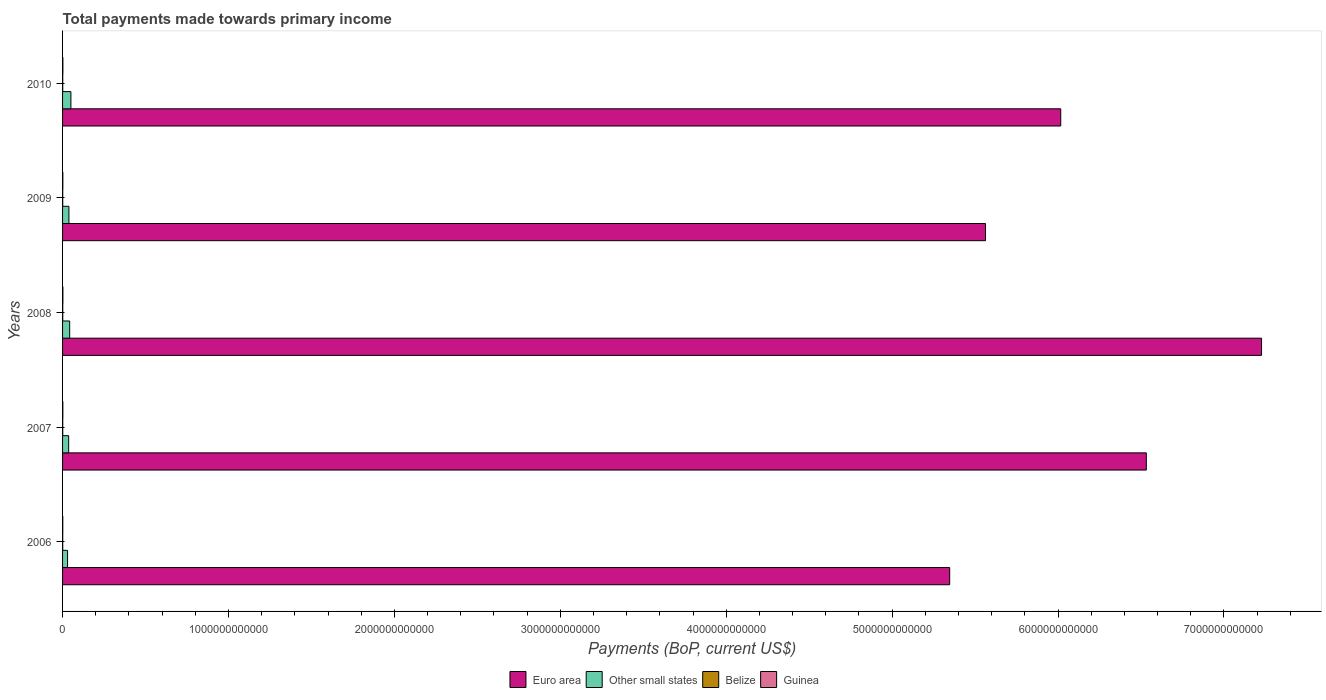How many groups of bars are there?
Your answer should be very brief. 5. How many bars are there on the 2nd tick from the top?
Ensure brevity in your answer.  4. What is the label of the 4th group of bars from the top?
Provide a succinct answer. 2007. What is the total payments made towards primary income in Other small states in 2009?
Provide a short and direct response. 3.83e+1. Across all years, what is the maximum total payments made towards primary income in Euro area?
Provide a short and direct response. 7.23e+12. Across all years, what is the minimum total payments made towards primary income in Other small states?
Your response must be concise. 3.01e+1. What is the total total payments made towards primary income in Other small states in the graph?
Your answer should be compact. 1.98e+11. What is the difference between the total payments made towards primary income in Belize in 2008 and that in 2010?
Ensure brevity in your answer.  1.57e+08. What is the difference between the total payments made towards primary income in Euro area in 2008 and the total payments made towards primary income in Belize in 2007?
Make the answer very short. 7.23e+12. What is the average total payments made towards primary income in Belize per year?
Your answer should be very brief. 9.70e+08. In the year 2006, what is the difference between the total payments made towards primary income in Euro area and total payments made towards primary income in Guinea?
Make the answer very short. 5.35e+12. What is the ratio of the total payments made towards primary income in Guinea in 2007 to that in 2010?
Provide a succinct answer. 0.86. What is the difference between the highest and the second highest total payments made towards primary income in Euro area?
Give a very brief answer. 6.94e+11. What is the difference between the highest and the lowest total payments made towards primary income in Guinea?
Your answer should be compact. 6.13e+08. In how many years, is the total payments made towards primary income in Other small states greater than the average total payments made towards primary income in Other small states taken over all years?
Your answer should be compact. 2. Is the sum of the total payments made towards primary income in Guinea in 2008 and 2009 greater than the maximum total payments made towards primary income in Euro area across all years?
Keep it short and to the point. No. What does the 2nd bar from the bottom in 2007 represents?
Offer a terse response. Other small states. How many bars are there?
Offer a very short reply. 20. How many years are there in the graph?
Offer a terse response. 5. What is the difference between two consecutive major ticks on the X-axis?
Ensure brevity in your answer.  1.00e+12. Does the graph contain grids?
Give a very brief answer. No. How are the legend labels stacked?
Your answer should be very brief. Horizontal. What is the title of the graph?
Ensure brevity in your answer.  Total payments made towards primary income. What is the label or title of the X-axis?
Your answer should be compact. Payments (BoP, current US$). What is the label or title of the Y-axis?
Your response must be concise. Years. What is the Payments (BoP, current US$) in Euro area in 2006?
Keep it short and to the point. 5.35e+12. What is the Payments (BoP, current US$) of Other small states in 2006?
Give a very brief answer. 3.01e+1. What is the Payments (BoP, current US$) of Belize in 2006?
Provide a succinct answer. 8.85e+08. What is the Payments (BoP, current US$) of Guinea in 2006?
Keep it short and to the point. 1.30e+09. What is the Payments (BoP, current US$) in Euro area in 2007?
Your response must be concise. 6.53e+12. What is the Payments (BoP, current US$) of Other small states in 2007?
Ensure brevity in your answer.  3.68e+1. What is the Payments (BoP, current US$) in Belize in 2007?
Offer a very short reply. 9.69e+08. What is the Payments (BoP, current US$) of Guinea in 2007?
Your answer should be very brief. 1.64e+09. What is the Payments (BoP, current US$) of Euro area in 2008?
Provide a short and direct response. 7.23e+12. What is the Payments (BoP, current US$) in Other small states in 2008?
Give a very brief answer. 4.29e+1. What is the Payments (BoP, current US$) in Belize in 2008?
Provide a succinct answer. 1.13e+09. What is the Payments (BoP, current US$) of Guinea in 2008?
Provide a succinct answer. 1.91e+09. What is the Payments (BoP, current US$) in Euro area in 2009?
Provide a short and direct response. 5.56e+12. What is the Payments (BoP, current US$) in Other small states in 2009?
Keep it short and to the point. 3.83e+1. What is the Payments (BoP, current US$) of Belize in 2009?
Offer a terse response. 8.95e+08. What is the Payments (BoP, current US$) of Guinea in 2009?
Your response must be concise. 1.58e+09. What is the Payments (BoP, current US$) in Euro area in 2010?
Provide a short and direct response. 6.02e+12. What is the Payments (BoP, current US$) in Other small states in 2010?
Provide a succinct answer. 5.03e+1. What is the Payments (BoP, current US$) in Belize in 2010?
Make the answer very short. 9.72e+08. What is the Payments (BoP, current US$) of Guinea in 2010?
Ensure brevity in your answer.  1.89e+09. Across all years, what is the maximum Payments (BoP, current US$) of Euro area?
Your answer should be very brief. 7.23e+12. Across all years, what is the maximum Payments (BoP, current US$) of Other small states?
Provide a succinct answer. 5.03e+1. Across all years, what is the maximum Payments (BoP, current US$) in Belize?
Make the answer very short. 1.13e+09. Across all years, what is the maximum Payments (BoP, current US$) of Guinea?
Make the answer very short. 1.91e+09. Across all years, what is the minimum Payments (BoP, current US$) of Euro area?
Make the answer very short. 5.35e+12. Across all years, what is the minimum Payments (BoP, current US$) in Other small states?
Provide a succinct answer. 3.01e+1. Across all years, what is the minimum Payments (BoP, current US$) of Belize?
Your answer should be very brief. 8.85e+08. Across all years, what is the minimum Payments (BoP, current US$) in Guinea?
Provide a short and direct response. 1.30e+09. What is the total Payments (BoP, current US$) in Euro area in the graph?
Provide a short and direct response. 3.07e+13. What is the total Payments (BoP, current US$) in Other small states in the graph?
Offer a terse response. 1.98e+11. What is the total Payments (BoP, current US$) in Belize in the graph?
Keep it short and to the point. 4.85e+09. What is the total Payments (BoP, current US$) of Guinea in the graph?
Keep it short and to the point. 8.32e+09. What is the difference between the Payments (BoP, current US$) in Euro area in 2006 and that in 2007?
Your response must be concise. -1.19e+12. What is the difference between the Payments (BoP, current US$) in Other small states in 2006 and that in 2007?
Make the answer very short. -6.70e+09. What is the difference between the Payments (BoP, current US$) in Belize in 2006 and that in 2007?
Provide a short and direct response. -8.34e+07. What is the difference between the Payments (BoP, current US$) of Guinea in 2006 and that in 2007?
Give a very brief answer. -3.39e+08. What is the difference between the Payments (BoP, current US$) in Euro area in 2006 and that in 2008?
Your answer should be compact. -1.88e+12. What is the difference between the Payments (BoP, current US$) of Other small states in 2006 and that in 2008?
Provide a short and direct response. -1.28e+1. What is the difference between the Payments (BoP, current US$) in Belize in 2006 and that in 2008?
Your answer should be very brief. -2.44e+08. What is the difference between the Payments (BoP, current US$) of Guinea in 2006 and that in 2008?
Offer a very short reply. -6.13e+08. What is the difference between the Payments (BoP, current US$) in Euro area in 2006 and that in 2009?
Offer a very short reply. -2.16e+11. What is the difference between the Payments (BoP, current US$) of Other small states in 2006 and that in 2009?
Ensure brevity in your answer.  -8.19e+09. What is the difference between the Payments (BoP, current US$) of Belize in 2006 and that in 2009?
Provide a short and direct response. -9.58e+06. What is the difference between the Payments (BoP, current US$) of Guinea in 2006 and that in 2009?
Your answer should be compact. -2.83e+08. What is the difference between the Payments (BoP, current US$) in Euro area in 2006 and that in 2010?
Make the answer very short. -6.69e+11. What is the difference between the Payments (BoP, current US$) in Other small states in 2006 and that in 2010?
Provide a short and direct response. -2.01e+1. What is the difference between the Payments (BoP, current US$) in Belize in 2006 and that in 2010?
Provide a short and direct response. -8.63e+07. What is the difference between the Payments (BoP, current US$) in Guinea in 2006 and that in 2010?
Your answer should be very brief. -5.94e+08. What is the difference between the Payments (BoP, current US$) in Euro area in 2007 and that in 2008?
Provide a short and direct response. -6.94e+11. What is the difference between the Payments (BoP, current US$) of Other small states in 2007 and that in 2008?
Your response must be concise. -6.08e+09. What is the difference between the Payments (BoP, current US$) of Belize in 2007 and that in 2008?
Offer a very short reply. -1.60e+08. What is the difference between the Payments (BoP, current US$) of Guinea in 2007 and that in 2008?
Make the answer very short. -2.75e+08. What is the difference between the Payments (BoP, current US$) of Euro area in 2007 and that in 2009?
Give a very brief answer. 9.69e+11. What is the difference between the Payments (BoP, current US$) in Other small states in 2007 and that in 2009?
Ensure brevity in your answer.  -1.49e+09. What is the difference between the Payments (BoP, current US$) of Belize in 2007 and that in 2009?
Offer a terse response. 7.38e+07. What is the difference between the Payments (BoP, current US$) in Guinea in 2007 and that in 2009?
Offer a very short reply. 5.57e+07. What is the difference between the Payments (BoP, current US$) of Euro area in 2007 and that in 2010?
Your answer should be compact. 5.16e+11. What is the difference between the Payments (BoP, current US$) of Other small states in 2007 and that in 2010?
Give a very brief answer. -1.34e+1. What is the difference between the Payments (BoP, current US$) of Belize in 2007 and that in 2010?
Keep it short and to the point. -2.94e+06. What is the difference between the Payments (BoP, current US$) in Guinea in 2007 and that in 2010?
Ensure brevity in your answer.  -2.56e+08. What is the difference between the Payments (BoP, current US$) in Euro area in 2008 and that in 2009?
Your answer should be compact. 1.66e+12. What is the difference between the Payments (BoP, current US$) of Other small states in 2008 and that in 2009?
Provide a short and direct response. 4.59e+09. What is the difference between the Payments (BoP, current US$) in Belize in 2008 and that in 2009?
Keep it short and to the point. 2.34e+08. What is the difference between the Payments (BoP, current US$) of Guinea in 2008 and that in 2009?
Provide a short and direct response. 3.30e+08. What is the difference between the Payments (BoP, current US$) of Euro area in 2008 and that in 2010?
Offer a terse response. 1.21e+12. What is the difference between the Payments (BoP, current US$) of Other small states in 2008 and that in 2010?
Keep it short and to the point. -7.36e+09. What is the difference between the Payments (BoP, current US$) of Belize in 2008 and that in 2010?
Provide a short and direct response. 1.57e+08. What is the difference between the Payments (BoP, current US$) of Guinea in 2008 and that in 2010?
Your response must be concise. 1.90e+07. What is the difference between the Payments (BoP, current US$) in Euro area in 2009 and that in 2010?
Provide a short and direct response. -4.54e+11. What is the difference between the Payments (BoP, current US$) of Other small states in 2009 and that in 2010?
Keep it short and to the point. -1.20e+1. What is the difference between the Payments (BoP, current US$) of Belize in 2009 and that in 2010?
Give a very brief answer. -7.67e+07. What is the difference between the Payments (BoP, current US$) in Guinea in 2009 and that in 2010?
Make the answer very short. -3.11e+08. What is the difference between the Payments (BoP, current US$) in Euro area in 2006 and the Payments (BoP, current US$) in Other small states in 2007?
Your answer should be compact. 5.31e+12. What is the difference between the Payments (BoP, current US$) of Euro area in 2006 and the Payments (BoP, current US$) of Belize in 2007?
Provide a succinct answer. 5.35e+12. What is the difference between the Payments (BoP, current US$) of Euro area in 2006 and the Payments (BoP, current US$) of Guinea in 2007?
Ensure brevity in your answer.  5.35e+12. What is the difference between the Payments (BoP, current US$) of Other small states in 2006 and the Payments (BoP, current US$) of Belize in 2007?
Your response must be concise. 2.92e+1. What is the difference between the Payments (BoP, current US$) of Other small states in 2006 and the Payments (BoP, current US$) of Guinea in 2007?
Give a very brief answer. 2.85e+1. What is the difference between the Payments (BoP, current US$) of Belize in 2006 and the Payments (BoP, current US$) of Guinea in 2007?
Your response must be concise. -7.51e+08. What is the difference between the Payments (BoP, current US$) in Euro area in 2006 and the Payments (BoP, current US$) in Other small states in 2008?
Your answer should be compact. 5.30e+12. What is the difference between the Payments (BoP, current US$) in Euro area in 2006 and the Payments (BoP, current US$) in Belize in 2008?
Ensure brevity in your answer.  5.35e+12. What is the difference between the Payments (BoP, current US$) in Euro area in 2006 and the Payments (BoP, current US$) in Guinea in 2008?
Your answer should be very brief. 5.35e+12. What is the difference between the Payments (BoP, current US$) of Other small states in 2006 and the Payments (BoP, current US$) of Belize in 2008?
Offer a very short reply. 2.90e+1. What is the difference between the Payments (BoP, current US$) of Other small states in 2006 and the Payments (BoP, current US$) of Guinea in 2008?
Offer a terse response. 2.82e+1. What is the difference between the Payments (BoP, current US$) in Belize in 2006 and the Payments (BoP, current US$) in Guinea in 2008?
Offer a very short reply. -1.03e+09. What is the difference between the Payments (BoP, current US$) in Euro area in 2006 and the Payments (BoP, current US$) in Other small states in 2009?
Ensure brevity in your answer.  5.31e+12. What is the difference between the Payments (BoP, current US$) of Euro area in 2006 and the Payments (BoP, current US$) of Belize in 2009?
Provide a short and direct response. 5.35e+12. What is the difference between the Payments (BoP, current US$) of Euro area in 2006 and the Payments (BoP, current US$) of Guinea in 2009?
Offer a terse response. 5.35e+12. What is the difference between the Payments (BoP, current US$) of Other small states in 2006 and the Payments (BoP, current US$) of Belize in 2009?
Make the answer very short. 2.92e+1. What is the difference between the Payments (BoP, current US$) of Other small states in 2006 and the Payments (BoP, current US$) of Guinea in 2009?
Give a very brief answer. 2.85e+1. What is the difference between the Payments (BoP, current US$) in Belize in 2006 and the Payments (BoP, current US$) in Guinea in 2009?
Make the answer very short. -6.96e+08. What is the difference between the Payments (BoP, current US$) in Euro area in 2006 and the Payments (BoP, current US$) in Other small states in 2010?
Your answer should be very brief. 5.30e+12. What is the difference between the Payments (BoP, current US$) of Euro area in 2006 and the Payments (BoP, current US$) of Belize in 2010?
Give a very brief answer. 5.35e+12. What is the difference between the Payments (BoP, current US$) in Euro area in 2006 and the Payments (BoP, current US$) in Guinea in 2010?
Your answer should be compact. 5.35e+12. What is the difference between the Payments (BoP, current US$) of Other small states in 2006 and the Payments (BoP, current US$) of Belize in 2010?
Offer a very short reply. 2.91e+1. What is the difference between the Payments (BoP, current US$) in Other small states in 2006 and the Payments (BoP, current US$) in Guinea in 2010?
Your answer should be very brief. 2.82e+1. What is the difference between the Payments (BoP, current US$) in Belize in 2006 and the Payments (BoP, current US$) in Guinea in 2010?
Your answer should be compact. -1.01e+09. What is the difference between the Payments (BoP, current US$) of Euro area in 2007 and the Payments (BoP, current US$) of Other small states in 2008?
Your answer should be very brief. 6.49e+12. What is the difference between the Payments (BoP, current US$) of Euro area in 2007 and the Payments (BoP, current US$) of Belize in 2008?
Keep it short and to the point. 6.53e+12. What is the difference between the Payments (BoP, current US$) of Euro area in 2007 and the Payments (BoP, current US$) of Guinea in 2008?
Your response must be concise. 6.53e+12. What is the difference between the Payments (BoP, current US$) of Other small states in 2007 and the Payments (BoP, current US$) of Belize in 2008?
Offer a terse response. 3.57e+1. What is the difference between the Payments (BoP, current US$) in Other small states in 2007 and the Payments (BoP, current US$) in Guinea in 2008?
Your answer should be compact. 3.49e+1. What is the difference between the Payments (BoP, current US$) of Belize in 2007 and the Payments (BoP, current US$) of Guinea in 2008?
Keep it short and to the point. -9.43e+08. What is the difference between the Payments (BoP, current US$) in Euro area in 2007 and the Payments (BoP, current US$) in Other small states in 2009?
Ensure brevity in your answer.  6.49e+12. What is the difference between the Payments (BoP, current US$) of Euro area in 2007 and the Payments (BoP, current US$) of Belize in 2009?
Offer a terse response. 6.53e+12. What is the difference between the Payments (BoP, current US$) in Euro area in 2007 and the Payments (BoP, current US$) in Guinea in 2009?
Ensure brevity in your answer.  6.53e+12. What is the difference between the Payments (BoP, current US$) in Other small states in 2007 and the Payments (BoP, current US$) in Belize in 2009?
Keep it short and to the point. 3.59e+1. What is the difference between the Payments (BoP, current US$) of Other small states in 2007 and the Payments (BoP, current US$) of Guinea in 2009?
Offer a very short reply. 3.52e+1. What is the difference between the Payments (BoP, current US$) in Belize in 2007 and the Payments (BoP, current US$) in Guinea in 2009?
Provide a short and direct response. -6.12e+08. What is the difference between the Payments (BoP, current US$) of Euro area in 2007 and the Payments (BoP, current US$) of Other small states in 2010?
Ensure brevity in your answer.  6.48e+12. What is the difference between the Payments (BoP, current US$) of Euro area in 2007 and the Payments (BoP, current US$) of Belize in 2010?
Offer a terse response. 6.53e+12. What is the difference between the Payments (BoP, current US$) of Euro area in 2007 and the Payments (BoP, current US$) of Guinea in 2010?
Your response must be concise. 6.53e+12. What is the difference between the Payments (BoP, current US$) of Other small states in 2007 and the Payments (BoP, current US$) of Belize in 2010?
Keep it short and to the point. 3.58e+1. What is the difference between the Payments (BoP, current US$) of Other small states in 2007 and the Payments (BoP, current US$) of Guinea in 2010?
Provide a short and direct response. 3.49e+1. What is the difference between the Payments (BoP, current US$) in Belize in 2007 and the Payments (BoP, current US$) in Guinea in 2010?
Your answer should be very brief. -9.24e+08. What is the difference between the Payments (BoP, current US$) in Euro area in 2008 and the Payments (BoP, current US$) in Other small states in 2009?
Your answer should be compact. 7.19e+12. What is the difference between the Payments (BoP, current US$) in Euro area in 2008 and the Payments (BoP, current US$) in Belize in 2009?
Your answer should be very brief. 7.23e+12. What is the difference between the Payments (BoP, current US$) of Euro area in 2008 and the Payments (BoP, current US$) of Guinea in 2009?
Offer a terse response. 7.23e+12. What is the difference between the Payments (BoP, current US$) in Other small states in 2008 and the Payments (BoP, current US$) in Belize in 2009?
Provide a succinct answer. 4.20e+1. What is the difference between the Payments (BoP, current US$) of Other small states in 2008 and the Payments (BoP, current US$) of Guinea in 2009?
Provide a short and direct response. 4.13e+1. What is the difference between the Payments (BoP, current US$) of Belize in 2008 and the Payments (BoP, current US$) of Guinea in 2009?
Your answer should be compact. -4.52e+08. What is the difference between the Payments (BoP, current US$) in Euro area in 2008 and the Payments (BoP, current US$) in Other small states in 2010?
Give a very brief answer. 7.18e+12. What is the difference between the Payments (BoP, current US$) of Euro area in 2008 and the Payments (BoP, current US$) of Belize in 2010?
Provide a short and direct response. 7.23e+12. What is the difference between the Payments (BoP, current US$) in Euro area in 2008 and the Payments (BoP, current US$) in Guinea in 2010?
Offer a very short reply. 7.22e+12. What is the difference between the Payments (BoP, current US$) in Other small states in 2008 and the Payments (BoP, current US$) in Belize in 2010?
Your response must be concise. 4.19e+1. What is the difference between the Payments (BoP, current US$) of Other small states in 2008 and the Payments (BoP, current US$) of Guinea in 2010?
Ensure brevity in your answer.  4.10e+1. What is the difference between the Payments (BoP, current US$) of Belize in 2008 and the Payments (BoP, current US$) of Guinea in 2010?
Your response must be concise. -7.64e+08. What is the difference between the Payments (BoP, current US$) of Euro area in 2009 and the Payments (BoP, current US$) of Other small states in 2010?
Your answer should be compact. 5.51e+12. What is the difference between the Payments (BoP, current US$) of Euro area in 2009 and the Payments (BoP, current US$) of Belize in 2010?
Offer a very short reply. 5.56e+12. What is the difference between the Payments (BoP, current US$) of Euro area in 2009 and the Payments (BoP, current US$) of Guinea in 2010?
Make the answer very short. 5.56e+12. What is the difference between the Payments (BoP, current US$) of Other small states in 2009 and the Payments (BoP, current US$) of Belize in 2010?
Your answer should be compact. 3.73e+1. What is the difference between the Payments (BoP, current US$) in Other small states in 2009 and the Payments (BoP, current US$) in Guinea in 2010?
Provide a succinct answer. 3.64e+1. What is the difference between the Payments (BoP, current US$) of Belize in 2009 and the Payments (BoP, current US$) of Guinea in 2010?
Offer a very short reply. -9.97e+08. What is the average Payments (BoP, current US$) in Euro area per year?
Ensure brevity in your answer.  6.14e+12. What is the average Payments (BoP, current US$) in Other small states per year?
Provide a short and direct response. 3.97e+1. What is the average Payments (BoP, current US$) in Belize per year?
Give a very brief answer. 9.70e+08. What is the average Payments (BoP, current US$) in Guinea per year?
Give a very brief answer. 1.66e+09. In the year 2006, what is the difference between the Payments (BoP, current US$) in Euro area and Payments (BoP, current US$) in Other small states?
Offer a terse response. 5.32e+12. In the year 2006, what is the difference between the Payments (BoP, current US$) of Euro area and Payments (BoP, current US$) of Belize?
Provide a succinct answer. 5.35e+12. In the year 2006, what is the difference between the Payments (BoP, current US$) in Euro area and Payments (BoP, current US$) in Guinea?
Keep it short and to the point. 5.35e+12. In the year 2006, what is the difference between the Payments (BoP, current US$) of Other small states and Payments (BoP, current US$) of Belize?
Offer a very short reply. 2.92e+1. In the year 2006, what is the difference between the Payments (BoP, current US$) of Other small states and Payments (BoP, current US$) of Guinea?
Make the answer very short. 2.88e+1. In the year 2006, what is the difference between the Payments (BoP, current US$) in Belize and Payments (BoP, current US$) in Guinea?
Offer a very short reply. -4.13e+08. In the year 2007, what is the difference between the Payments (BoP, current US$) in Euro area and Payments (BoP, current US$) in Other small states?
Ensure brevity in your answer.  6.50e+12. In the year 2007, what is the difference between the Payments (BoP, current US$) in Euro area and Payments (BoP, current US$) in Belize?
Your answer should be compact. 6.53e+12. In the year 2007, what is the difference between the Payments (BoP, current US$) in Euro area and Payments (BoP, current US$) in Guinea?
Your answer should be compact. 6.53e+12. In the year 2007, what is the difference between the Payments (BoP, current US$) in Other small states and Payments (BoP, current US$) in Belize?
Your response must be concise. 3.58e+1. In the year 2007, what is the difference between the Payments (BoP, current US$) of Other small states and Payments (BoP, current US$) of Guinea?
Provide a succinct answer. 3.52e+1. In the year 2007, what is the difference between the Payments (BoP, current US$) of Belize and Payments (BoP, current US$) of Guinea?
Ensure brevity in your answer.  -6.68e+08. In the year 2008, what is the difference between the Payments (BoP, current US$) in Euro area and Payments (BoP, current US$) in Other small states?
Keep it short and to the point. 7.18e+12. In the year 2008, what is the difference between the Payments (BoP, current US$) in Euro area and Payments (BoP, current US$) in Belize?
Your response must be concise. 7.23e+12. In the year 2008, what is the difference between the Payments (BoP, current US$) of Euro area and Payments (BoP, current US$) of Guinea?
Give a very brief answer. 7.22e+12. In the year 2008, what is the difference between the Payments (BoP, current US$) of Other small states and Payments (BoP, current US$) of Belize?
Keep it short and to the point. 4.18e+1. In the year 2008, what is the difference between the Payments (BoP, current US$) in Other small states and Payments (BoP, current US$) in Guinea?
Provide a succinct answer. 4.10e+1. In the year 2008, what is the difference between the Payments (BoP, current US$) of Belize and Payments (BoP, current US$) of Guinea?
Your response must be concise. -7.83e+08. In the year 2009, what is the difference between the Payments (BoP, current US$) of Euro area and Payments (BoP, current US$) of Other small states?
Provide a succinct answer. 5.52e+12. In the year 2009, what is the difference between the Payments (BoP, current US$) in Euro area and Payments (BoP, current US$) in Belize?
Make the answer very short. 5.56e+12. In the year 2009, what is the difference between the Payments (BoP, current US$) in Euro area and Payments (BoP, current US$) in Guinea?
Provide a short and direct response. 5.56e+12. In the year 2009, what is the difference between the Payments (BoP, current US$) of Other small states and Payments (BoP, current US$) of Belize?
Your response must be concise. 3.74e+1. In the year 2009, what is the difference between the Payments (BoP, current US$) of Other small states and Payments (BoP, current US$) of Guinea?
Your response must be concise. 3.67e+1. In the year 2009, what is the difference between the Payments (BoP, current US$) in Belize and Payments (BoP, current US$) in Guinea?
Offer a very short reply. -6.86e+08. In the year 2010, what is the difference between the Payments (BoP, current US$) of Euro area and Payments (BoP, current US$) of Other small states?
Offer a terse response. 5.97e+12. In the year 2010, what is the difference between the Payments (BoP, current US$) of Euro area and Payments (BoP, current US$) of Belize?
Your answer should be compact. 6.02e+12. In the year 2010, what is the difference between the Payments (BoP, current US$) of Euro area and Payments (BoP, current US$) of Guinea?
Offer a very short reply. 6.01e+12. In the year 2010, what is the difference between the Payments (BoP, current US$) of Other small states and Payments (BoP, current US$) of Belize?
Your answer should be very brief. 4.93e+1. In the year 2010, what is the difference between the Payments (BoP, current US$) of Other small states and Payments (BoP, current US$) of Guinea?
Offer a terse response. 4.84e+1. In the year 2010, what is the difference between the Payments (BoP, current US$) in Belize and Payments (BoP, current US$) in Guinea?
Give a very brief answer. -9.21e+08. What is the ratio of the Payments (BoP, current US$) of Euro area in 2006 to that in 2007?
Your answer should be very brief. 0.82. What is the ratio of the Payments (BoP, current US$) in Other small states in 2006 to that in 2007?
Keep it short and to the point. 0.82. What is the ratio of the Payments (BoP, current US$) in Belize in 2006 to that in 2007?
Give a very brief answer. 0.91. What is the ratio of the Payments (BoP, current US$) in Guinea in 2006 to that in 2007?
Offer a terse response. 0.79. What is the ratio of the Payments (BoP, current US$) of Euro area in 2006 to that in 2008?
Your answer should be very brief. 0.74. What is the ratio of the Payments (BoP, current US$) of Other small states in 2006 to that in 2008?
Offer a terse response. 0.7. What is the ratio of the Payments (BoP, current US$) of Belize in 2006 to that in 2008?
Make the answer very short. 0.78. What is the ratio of the Payments (BoP, current US$) in Guinea in 2006 to that in 2008?
Your response must be concise. 0.68. What is the ratio of the Payments (BoP, current US$) of Euro area in 2006 to that in 2009?
Your answer should be very brief. 0.96. What is the ratio of the Payments (BoP, current US$) of Other small states in 2006 to that in 2009?
Your response must be concise. 0.79. What is the ratio of the Payments (BoP, current US$) of Belize in 2006 to that in 2009?
Ensure brevity in your answer.  0.99. What is the ratio of the Payments (BoP, current US$) of Guinea in 2006 to that in 2009?
Your response must be concise. 0.82. What is the ratio of the Payments (BoP, current US$) in Euro area in 2006 to that in 2010?
Offer a terse response. 0.89. What is the ratio of the Payments (BoP, current US$) in Other small states in 2006 to that in 2010?
Your answer should be very brief. 0.6. What is the ratio of the Payments (BoP, current US$) in Belize in 2006 to that in 2010?
Provide a short and direct response. 0.91. What is the ratio of the Payments (BoP, current US$) of Guinea in 2006 to that in 2010?
Give a very brief answer. 0.69. What is the ratio of the Payments (BoP, current US$) in Euro area in 2007 to that in 2008?
Your answer should be very brief. 0.9. What is the ratio of the Payments (BoP, current US$) of Other small states in 2007 to that in 2008?
Your answer should be compact. 0.86. What is the ratio of the Payments (BoP, current US$) of Belize in 2007 to that in 2008?
Your answer should be very brief. 0.86. What is the ratio of the Payments (BoP, current US$) in Guinea in 2007 to that in 2008?
Offer a very short reply. 0.86. What is the ratio of the Payments (BoP, current US$) in Euro area in 2007 to that in 2009?
Ensure brevity in your answer.  1.17. What is the ratio of the Payments (BoP, current US$) of Other small states in 2007 to that in 2009?
Your answer should be compact. 0.96. What is the ratio of the Payments (BoP, current US$) in Belize in 2007 to that in 2009?
Give a very brief answer. 1.08. What is the ratio of the Payments (BoP, current US$) in Guinea in 2007 to that in 2009?
Your response must be concise. 1.04. What is the ratio of the Payments (BoP, current US$) in Euro area in 2007 to that in 2010?
Provide a succinct answer. 1.09. What is the ratio of the Payments (BoP, current US$) in Other small states in 2007 to that in 2010?
Your answer should be very brief. 0.73. What is the ratio of the Payments (BoP, current US$) in Belize in 2007 to that in 2010?
Offer a terse response. 1. What is the ratio of the Payments (BoP, current US$) in Guinea in 2007 to that in 2010?
Offer a terse response. 0.86. What is the ratio of the Payments (BoP, current US$) in Euro area in 2008 to that in 2009?
Offer a very short reply. 1.3. What is the ratio of the Payments (BoP, current US$) of Other small states in 2008 to that in 2009?
Your answer should be very brief. 1.12. What is the ratio of the Payments (BoP, current US$) in Belize in 2008 to that in 2009?
Make the answer very short. 1.26. What is the ratio of the Payments (BoP, current US$) of Guinea in 2008 to that in 2009?
Provide a short and direct response. 1.21. What is the ratio of the Payments (BoP, current US$) of Euro area in 2008 to that in 2010?
Your answer should be compact. 1.2. What is the ratio of the Payments (BoP, current US$) of Other small states in 2008 to that in 2010?
Offer a very short reply. 0.85. What is the ratio of the Payments (BoP, current US$) in Belize in 2008 to that in 2010?
Your answer should be very brief. 1.16. What is the ratio of the Payments (BoP, current US$) in Euro area in 2009 to that in 2010?
Give a very brief answer. 0.92. What is the ratio of the Payments (BoP, current US$) in Other small states in 2009 to that in 2010?
Give a very brief answer. 0.76. What is the ratio of the Payments (BoP, current US$) in Belize in 2009 to that in 2010?
Provide a short and direct response. 0.92. What is the ratio of the Payments (BoP, current US$) in Guinea in 2009 to that in 2010?
Your response must be concise. 0.84. What is the difference between the highest and the second highest Payments (BoP, current US$) in Euro area?
Keep it short and to the point. 6.94e+11. What is the difference between the highest and the second highest Payments (BoP, current US$) of Other small states?
Offer a terse response. 7.36e+09. What is the difference between the highest and the second highest Payments (BoP, current US$) of Belize?
Provide a succinct answer. 1.57e+08. What is the difference between the highest and the second highest Payments (BoP, current US$) of Guinea?
Keep it short and to the point. 1.90e+07. What is the difference between the highest and the lowest Payments (BoP, current US$) of Euro area?
Provide a succinct answer. 1.88e+12. What is the difference between the highest and the lowest Payments (BoP, current US$) in Other small states?
Your answer should be very brief. 2.01e+1. What is the difference between the highest and the lowest Payments (BoP, current US$) of Belize?
Your response must be concise. 2.44e+08. What is the difference between the highest and the lowest Payments (BoP, current US$) in Guinea?
Your response must be concise. 6.13e+08. 